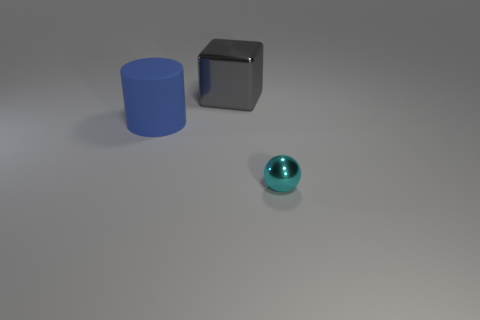Subtract all cylinders. How many objects are left? 2 Subtract 1 spheres. How many spheres are left? 0 Subtract all big gray cylinders. Subtract all metallic spheres. How many objects are left? 2 Add 2 blue cylinders. How many blue cylinders are left? 3 Add 1 cyan shiny spheres. How many cyan shiny spheres exist? 2 Add 3 cyan metallic things. How many objects exist? 6 Subtract 0 green blocks. How many objects are left? 3 